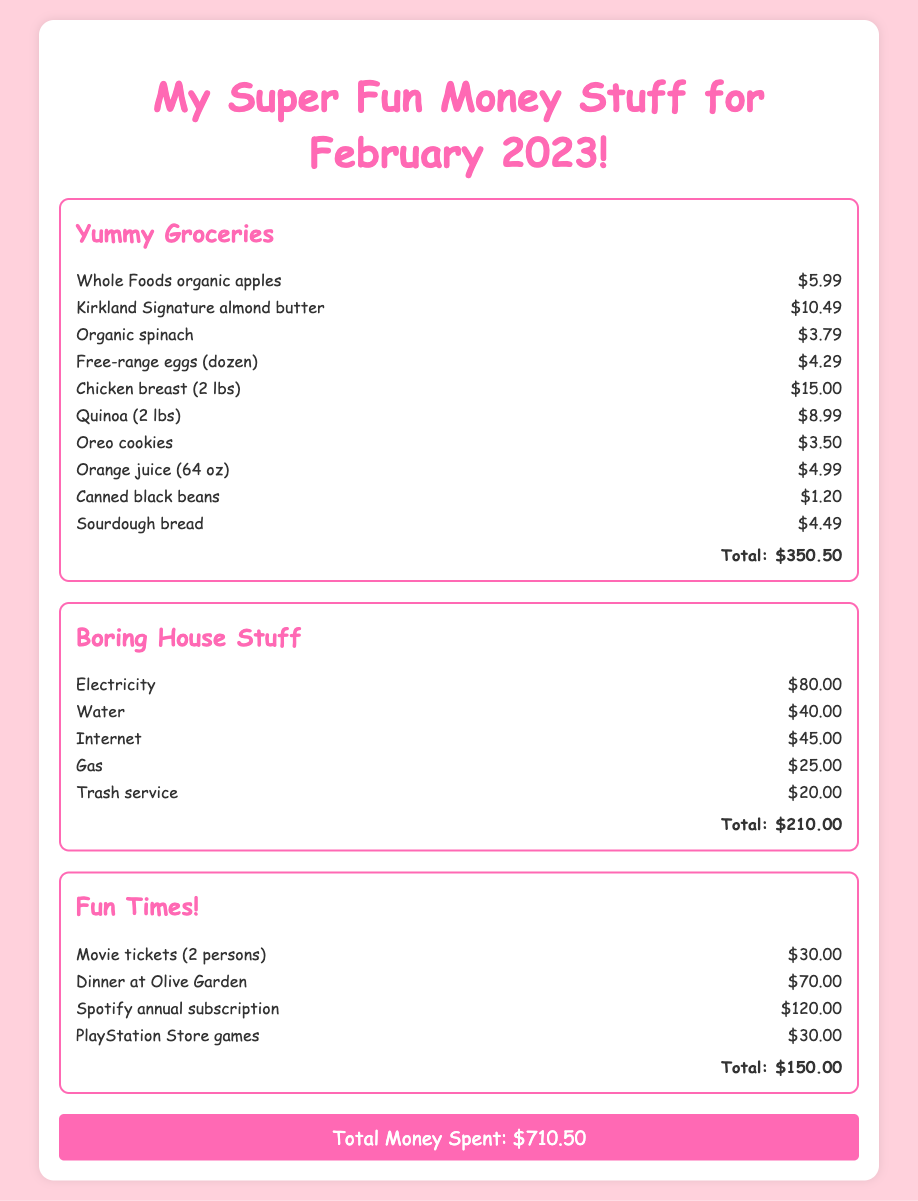What is the total cost of groceries? The total cost of groceries is summarized in the document under "Yummy Groceries" as $350.50.
Answer: $350.50 How much did I spend on utilities? The total amount spent on utilities is detailed under "Boring House Stuff" as $210.00.
Answer: $210.00 What is the cost of the Spotify annual subscription? The specific cost for the Spotify annual subscription is mentioned in the "Fun Times!" section as $120.00.
Answer: $120.00 Which category has the lowest total cost? The category with the lowest total cost can be determined from the totals listed, which is "Fun Times!" with $150.00.
Answer: Fun Times! What is the grand total spent for February 2023? The grand total summarizes all expenses from the various categories and is displayed at the bottom as $710.50.
Answer: $710.50 How much did I spend on entertainment? The total entertainment expenses under "Fun Times!" is indicated as $150.00.
Answer: $150.00 What item cost the most in the grocery category? The highest cost item in the grocery category is the "Chicken breast (2 lbs)," which costs $15.00.
Answer: Chicken breast (2 lbs) How much did I spend on gas? The document lists the cost for gas under "Boring House Stuff" as $25.00.
Answer: $25.00 